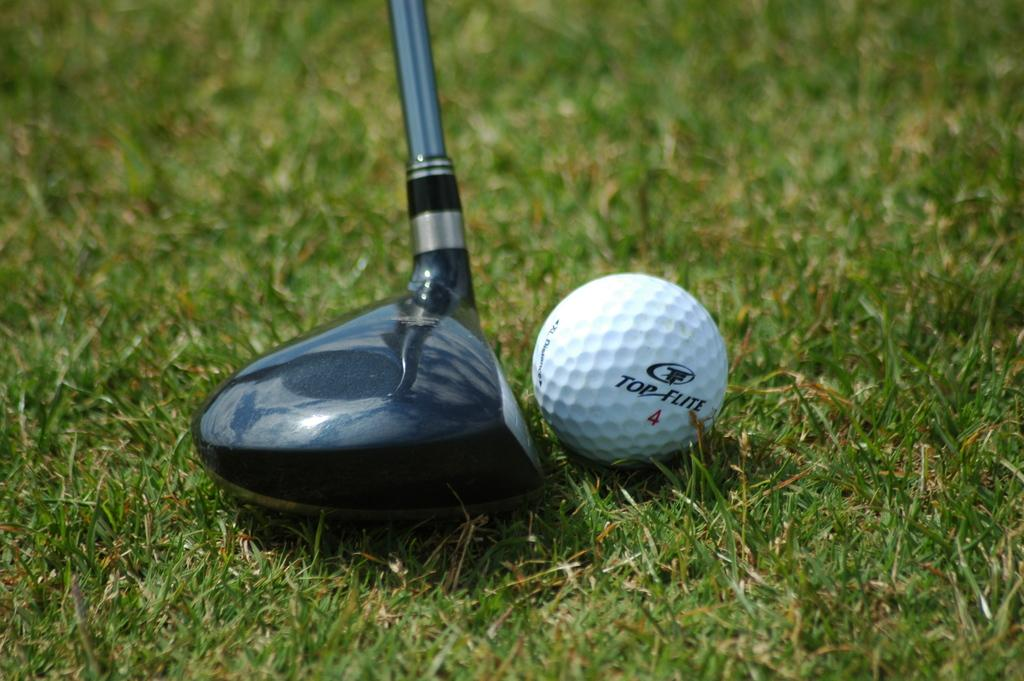What type of terrain is visible in the image? There is a grassy land in the image. What sport-related object can be seen in the image? There is a golf ball in the image. What is the golf ball likely being used for in the image? The golf ball is likely being used with a golf stick, which is also visible in the image. What type of hospital can be seen in the background of the image? There is no hospital present in the image; it features a grassy land with a golf ball and golf stick. What kind of toy is being played with in the image? There is no toy present in the image; it features a golf ball and golf stick, which are used for the sport of golf. 